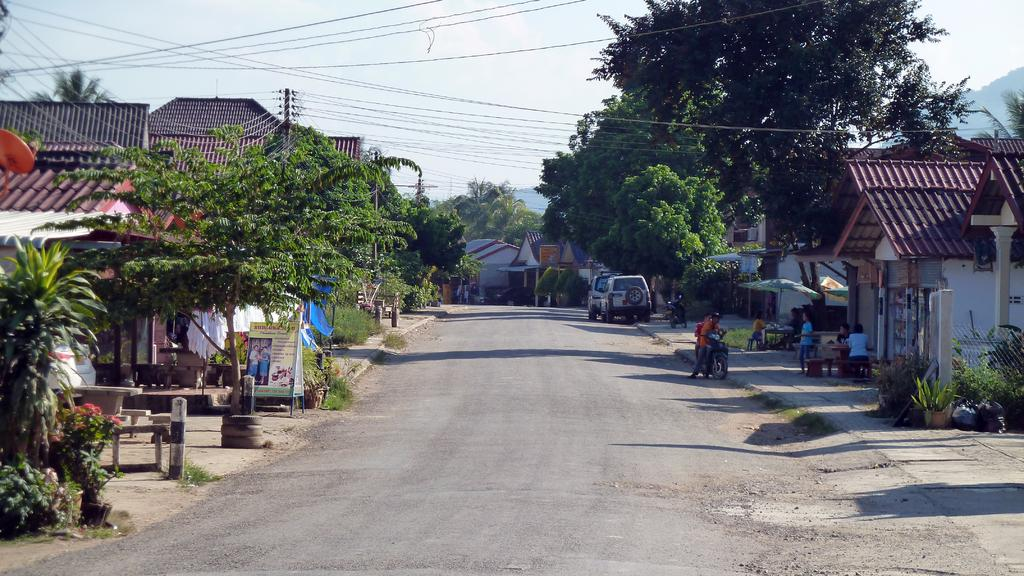What is the main feature of the image? There is a road in the image. What types of vehicles can be seen on the road? There are vehicles in the image. Are there any other modes of transportation visible? Yes, there are bikes in the image. Can you describe the people in the image? There are people in the image. What kind of structures are present in the image? There are houses in the image. What type of vegetation is visible in the image? There are plants, flowers, trees, and grass in the image. Are there any additional objects or decorations in the image? Yes, there are banners in the image. What else can be seen in the background of the image? The sky is visible in the background of the image. How many objects can be counted in the image? There are a few objects in the image. What other elements are present in the image? There are wires in the image. What company is hosting the summer event in the image? There is no company or summer event present in the image. 